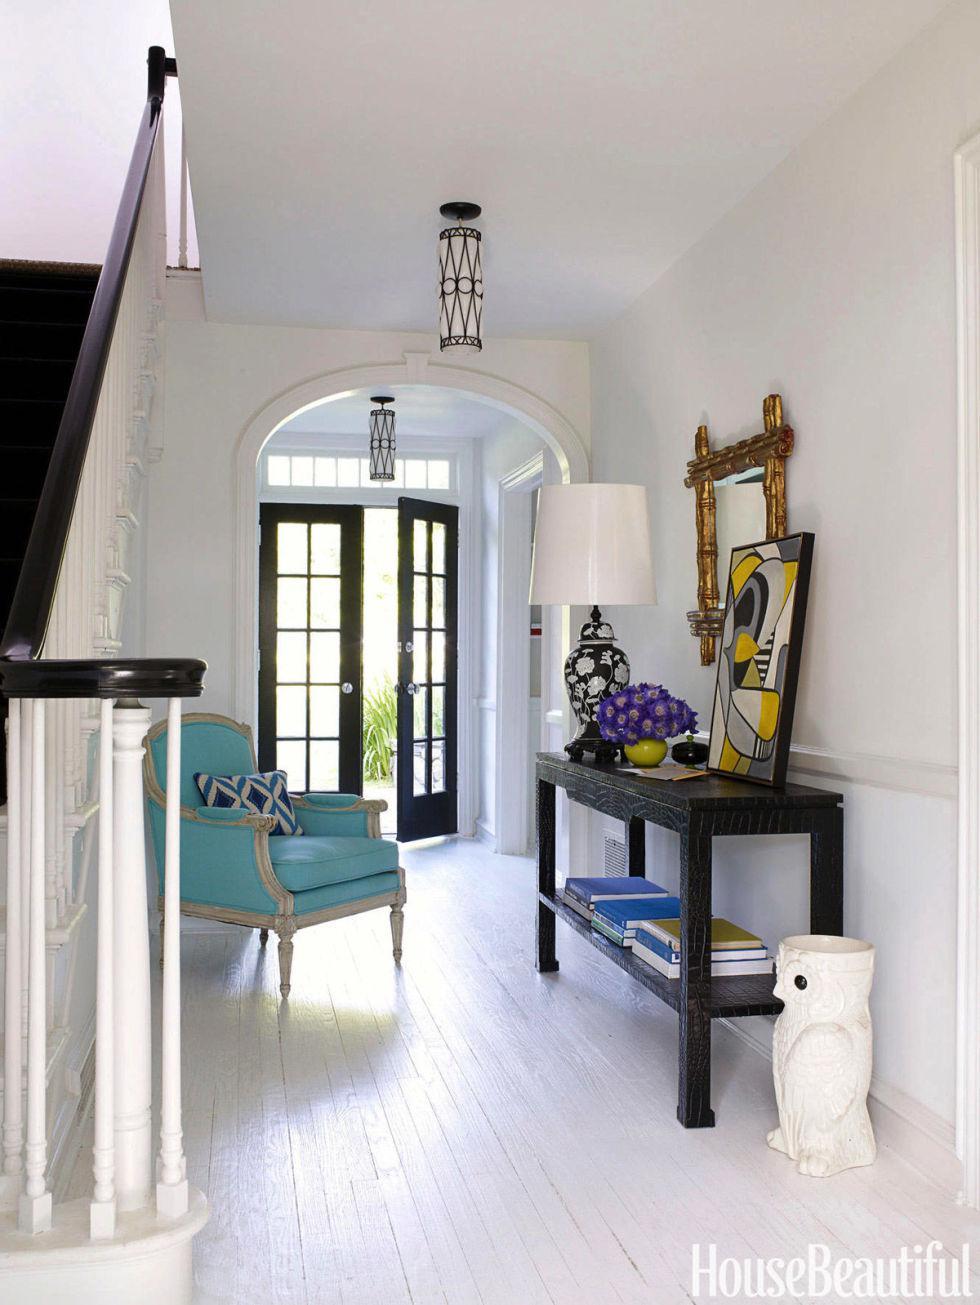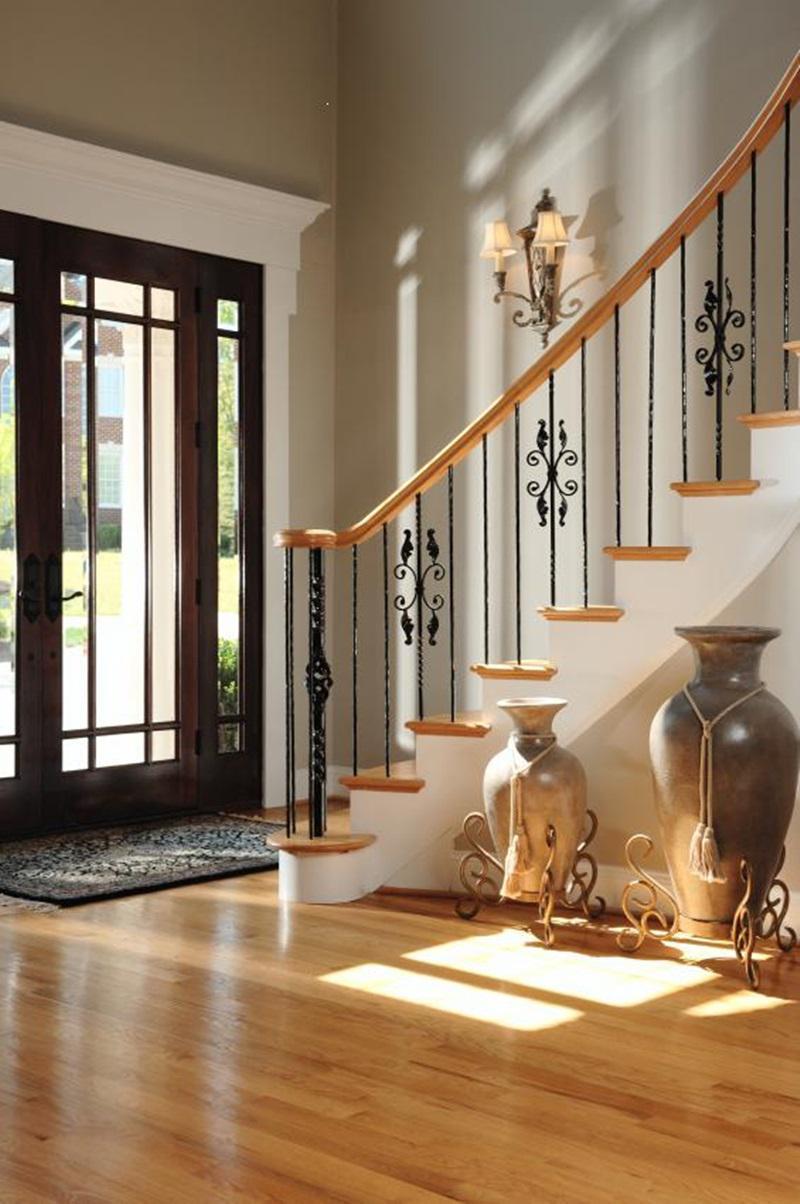The first image is the image on the left, the second image is the image on the right. For the images shown, is this caption "In at least one image there is a flight of stair facing left with a railing that has thin rods spaced out." true? Answer yes or no. Yes. The first image is the image on the left, the second image is the image on the right. Assess this claim about the two images: "One image contains two curved stairways with carpeted steps, white base boards, and brown handrails and balusters, and at least one of the stairways has white spindles.". Correct or not? Answer yes or no. No. 